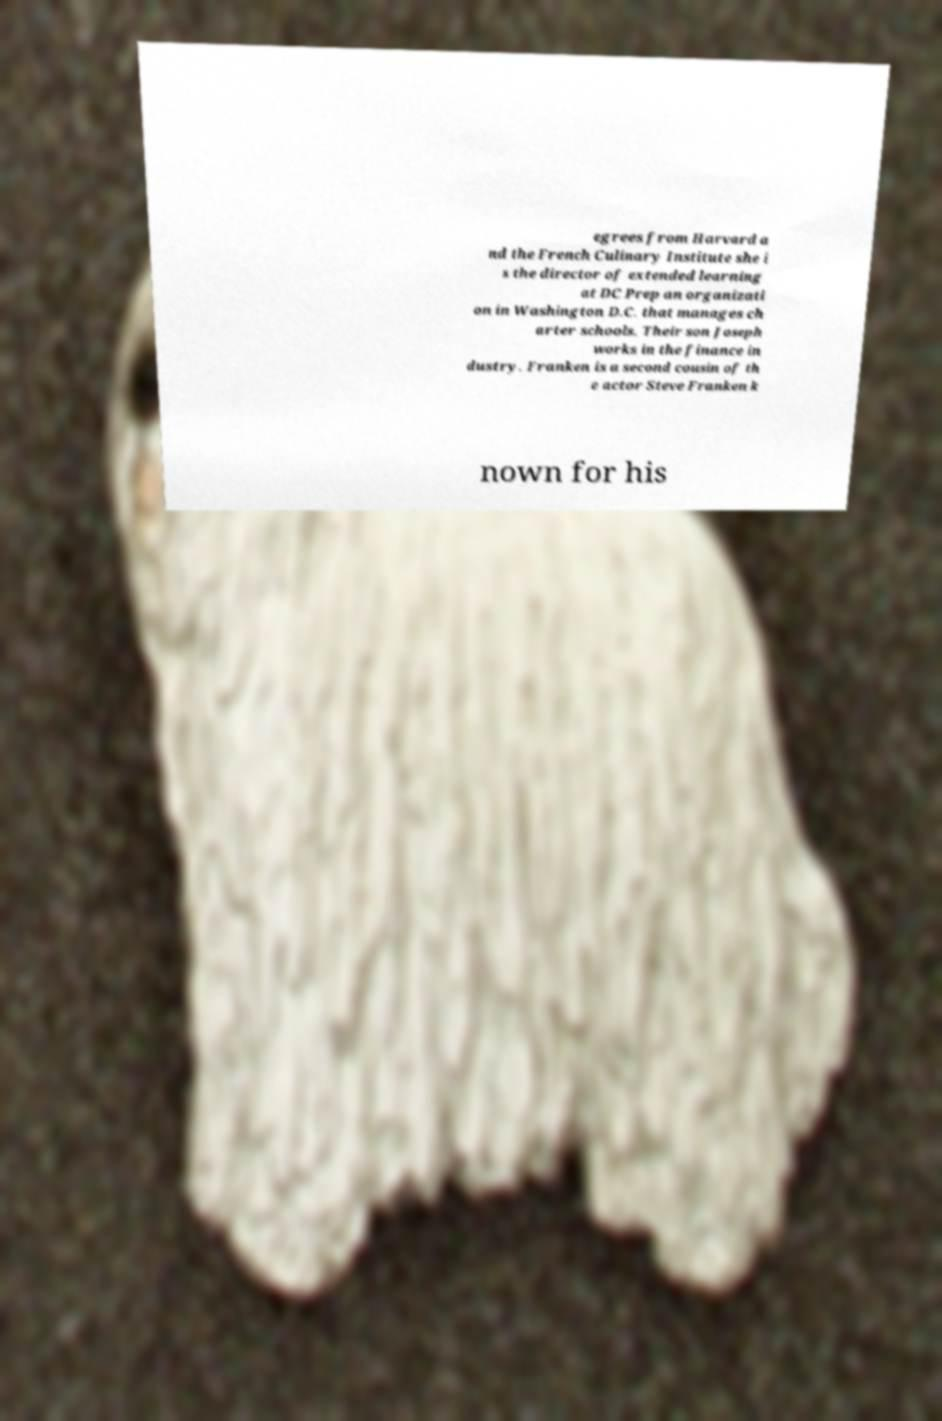Could you assist in decoding the text presented in this image and type it out clearly? egrees from Harvard a nd the French Culinary Institute she i s the director of extended learning at DC Prep an organizati on in Washington D.C. that manages ch arter schools. Their son Joseph works in the finance in dustry. Franken is a second cousin of th e actor Steve Franken k nown for his 